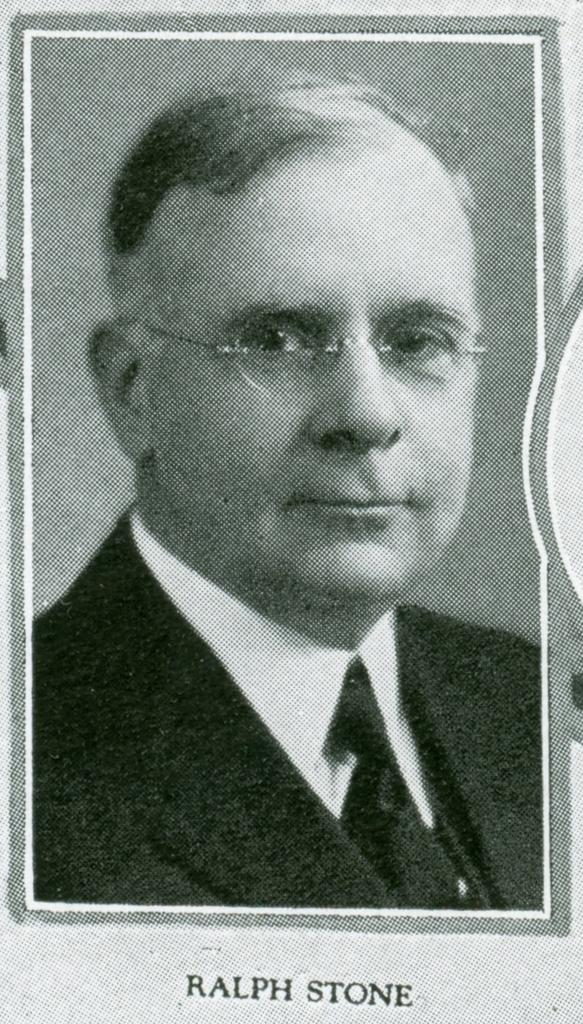What is the main subject of the image? The main subject of the image is a photo of a person. What can be seen on the photo of the person? There is text visible on the photo. Can you see the person in the photo kissing someone in the image? There is no indication of a kiss or any other physical interaction in the image. What type of tail is visible on the person in the photo? There is no tail visible on the person in the photo, as humans do not have tails. 